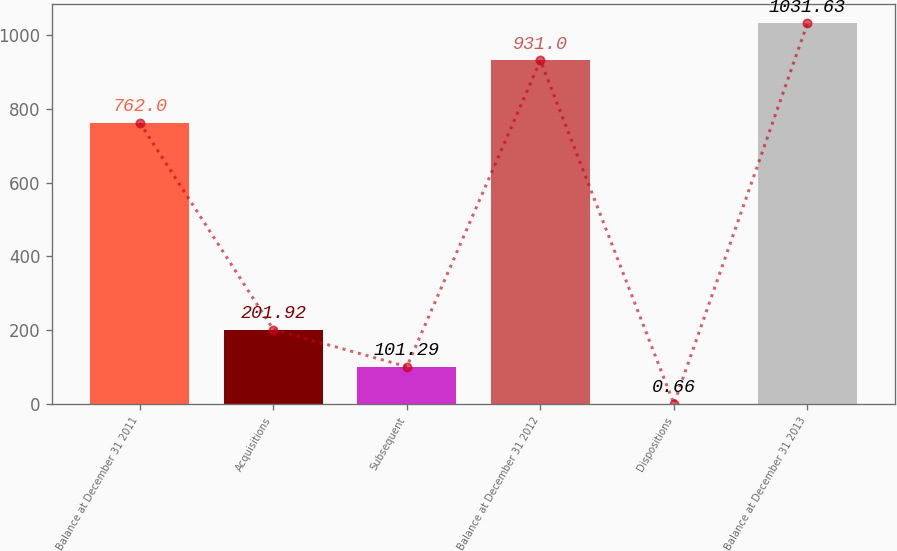<chart> <loc_0><loc_0><loc_500><loc_500><bar_chart><fcel>Balance at December 31 2011<fcel>Acquisitions<fcel>Subsequent<fcel>Balance at December 31 2012<fcel>Dispositions<fcel>Balance at December 31 2013<nl><fcel>762<fcel>201.92<fcel>101.29<fcel>931<fcel>0.66<fcel>1031.63<nl></chart> 